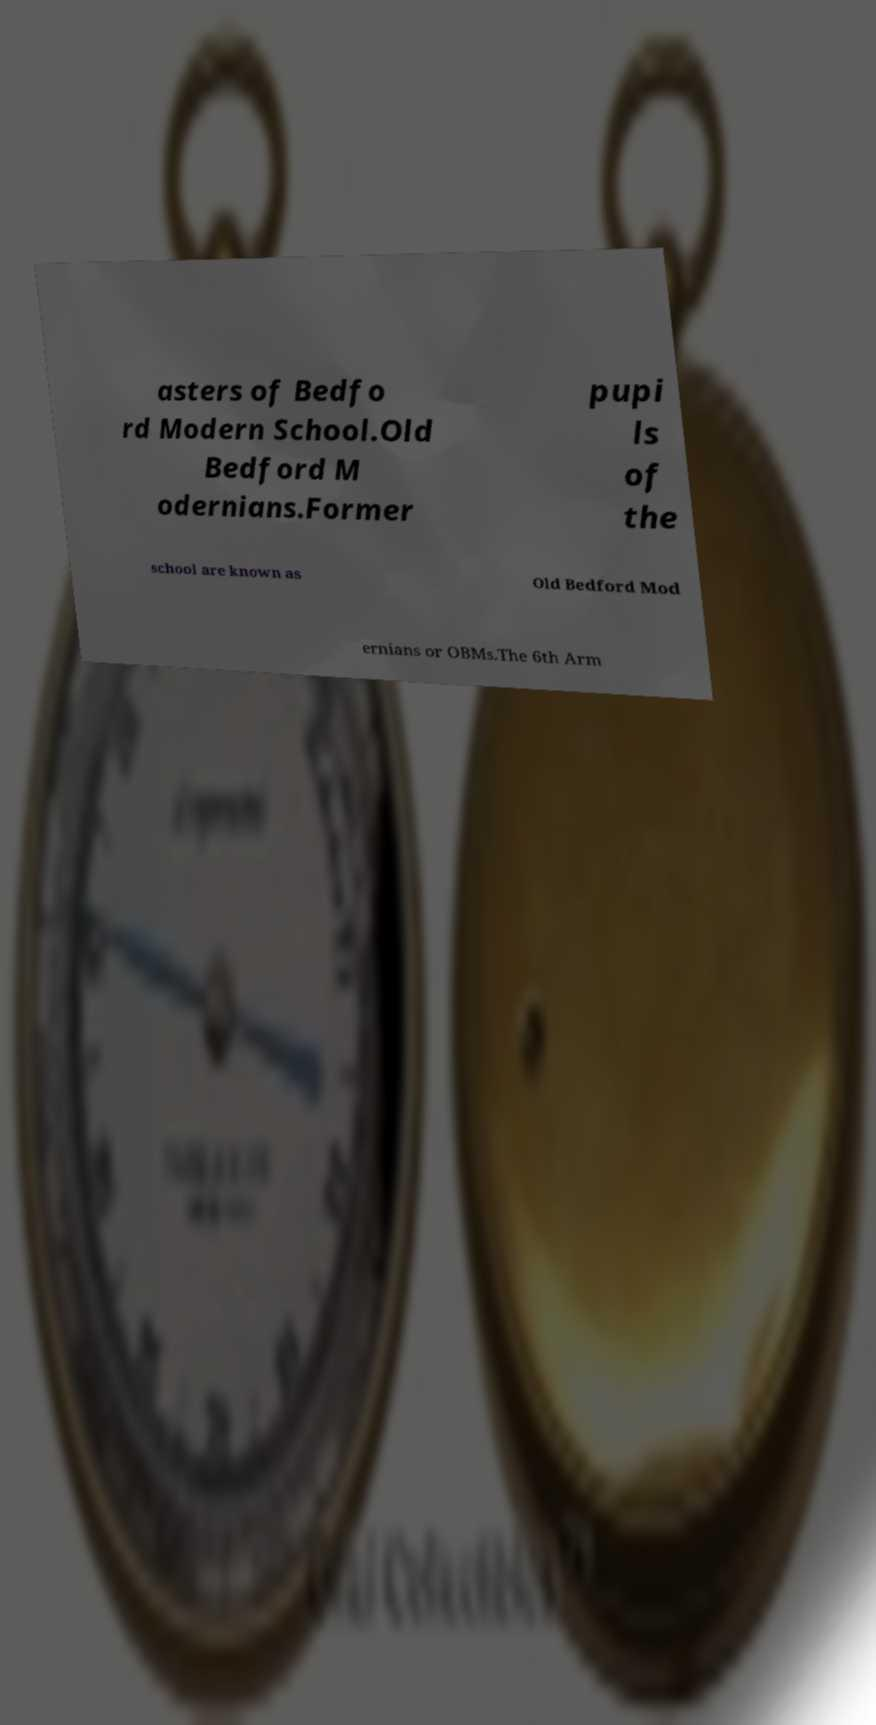What messages or text are displayed in this image? I need them in a readable, typed format. asters of Bedfo rd Modern School.Old Bedford M odernians.Former pupi ls of the school are known as Old Bedford Mod ernians or OBMs.The 6th Arm 